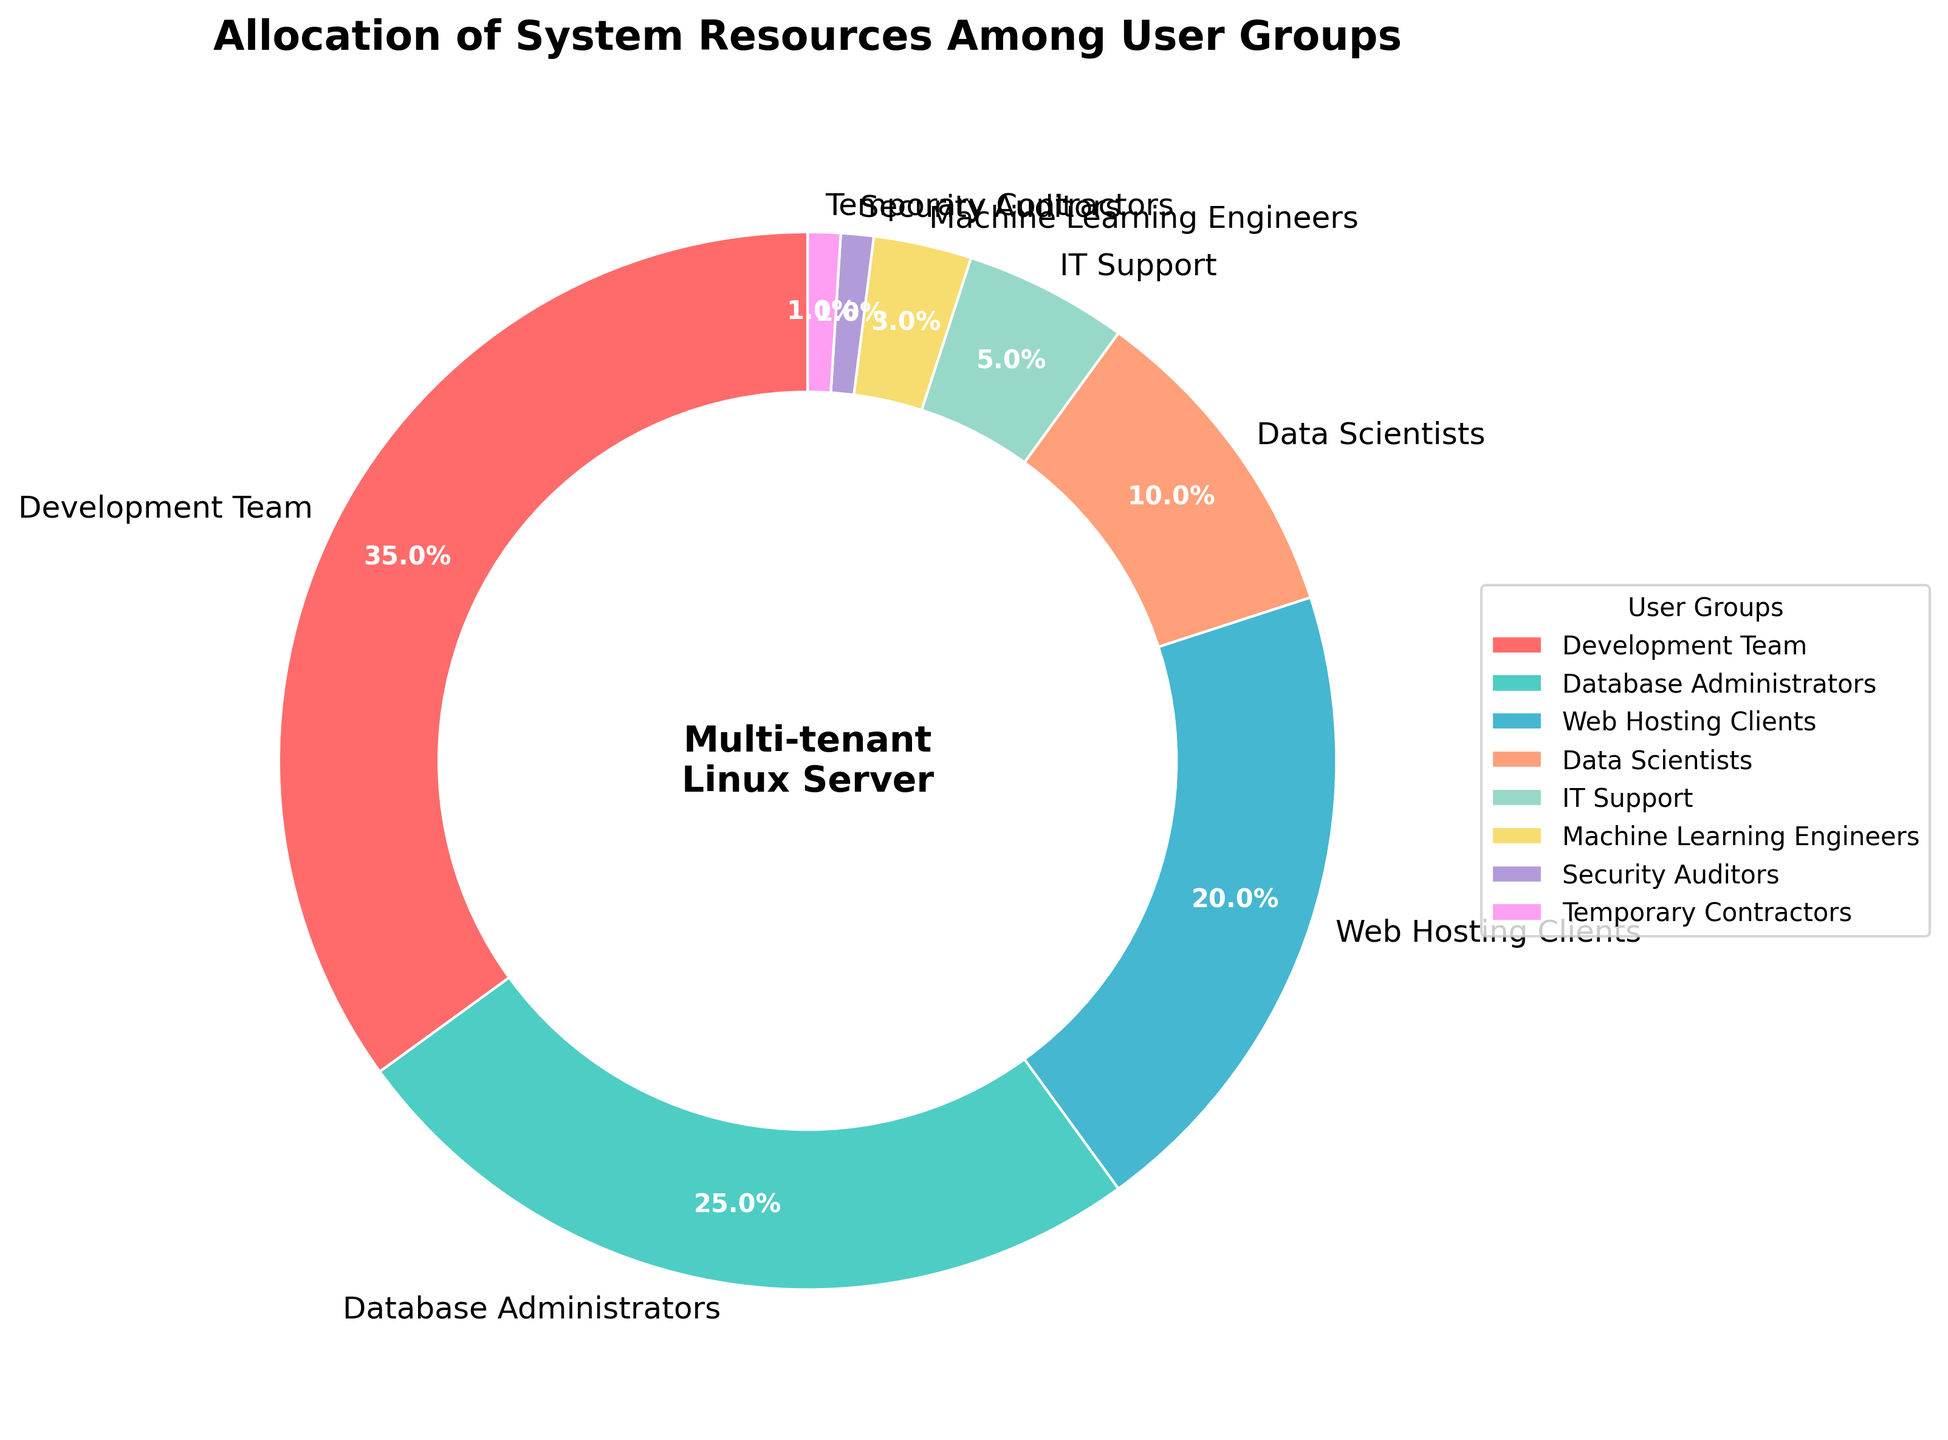Which user group has the highest resource allocation? The Development Team has the highest allocation of 35%, as visualized by the largest segment of the pie chart.
Answer: Development Team What is the total percentage allocation for Database Administrators and Data Scientists combined? The allocated percentages are 25% for Database Administrators and 10% for Data Scientists, which sum up to 25 + 10 = 35%.
Answer: 35% What is the difference in resource allocation between the Development Team and Machine Learning Engineers? The Development Team has 35% and Machine Learning Engineers have 3%. The difference is 35 - 3 = 32%.
Answer: 32% Which user group has the smallest resource allocation, and what is the percentage? The smallest segments of the pie chart are for Security Auditors and Temporary Contractors, each with an allocation of 1%.
Answer: Security Auditors and Temporary Contractors, 1% How much more resources does the Web Hosting Clients group use compared to IT Support? Web Hosting Clients have 20% while IT Support has 5%. The difference is 20 - 5 = 15%.
Answer: 15% If you combine the resource allocation of Temporary Contractors and Security Auditors, how does it compare to that of IT Support? Temporary Contractors and Security Auditors combined have 1% + 1% = 2%. IT Support has 5%. Therefore, IT Support uses more resources.
Answer: IT Support uses more resources What is the average resource allocation across all user groups? Total allocation sums to 100% across 8 groups. Average allocation is 100 / 8 = 12.5%.
Answer: 12.5% Which user group appears in light blue on the pie chart and what is its resource allocation? The Data Scientists group appears in light blue, and they are allocated 10% of the resources.
Answer: Data Scientists, 10% How many user groups have an allocation greater than or equal to 10%? Groups with >= 10% allocation are Development Team (35%), Database Administrators (25%), Web Hosting Clients (20%), and Data Scientists (10%). That's 4 groups in total.
Answer: 4 What proportion of the resource allocation is dedicated to user groups with less than 5% allocation? Groups with < 5% are IT Support (5%), Machine Learning Engineers (3%), Security Auditors (1%), and Temporary Contractors (1%), summing up to 5 + 3 + 1 + 1 = 10%.
Answer: 10% 